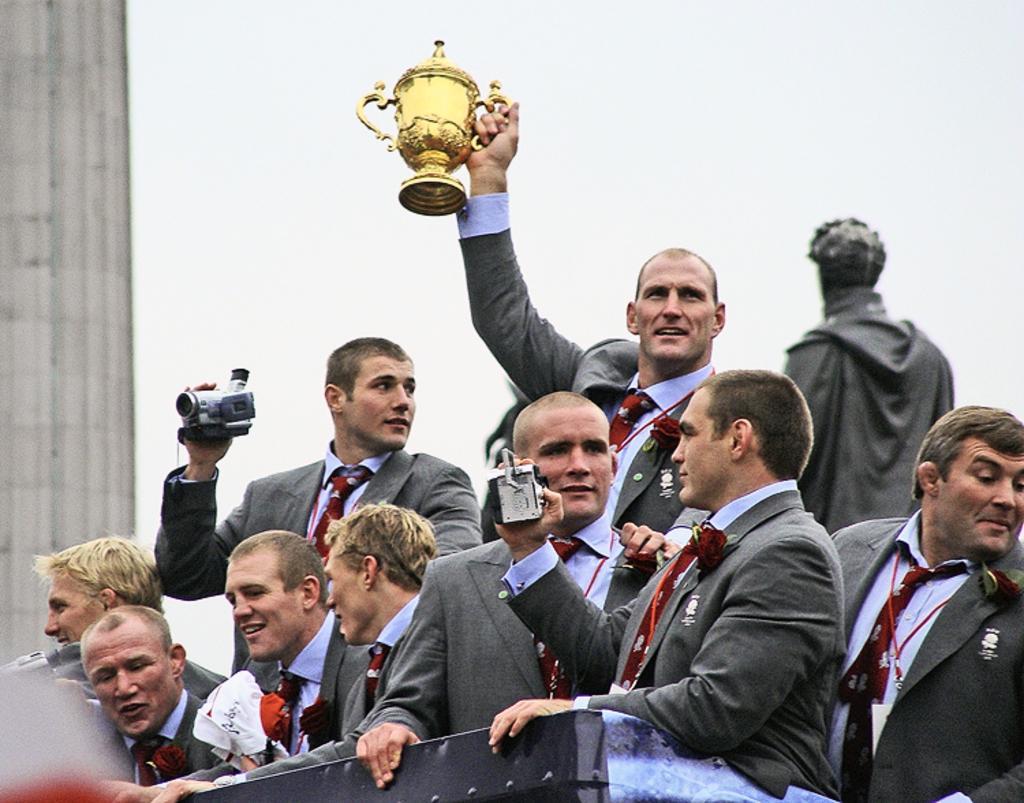Please provide a concise description of this image. In this picture there are group of people standing and there are two persons holding the cameras and there is a person holding the cup. On the left side of the image there is a building. At the top there is sky. 